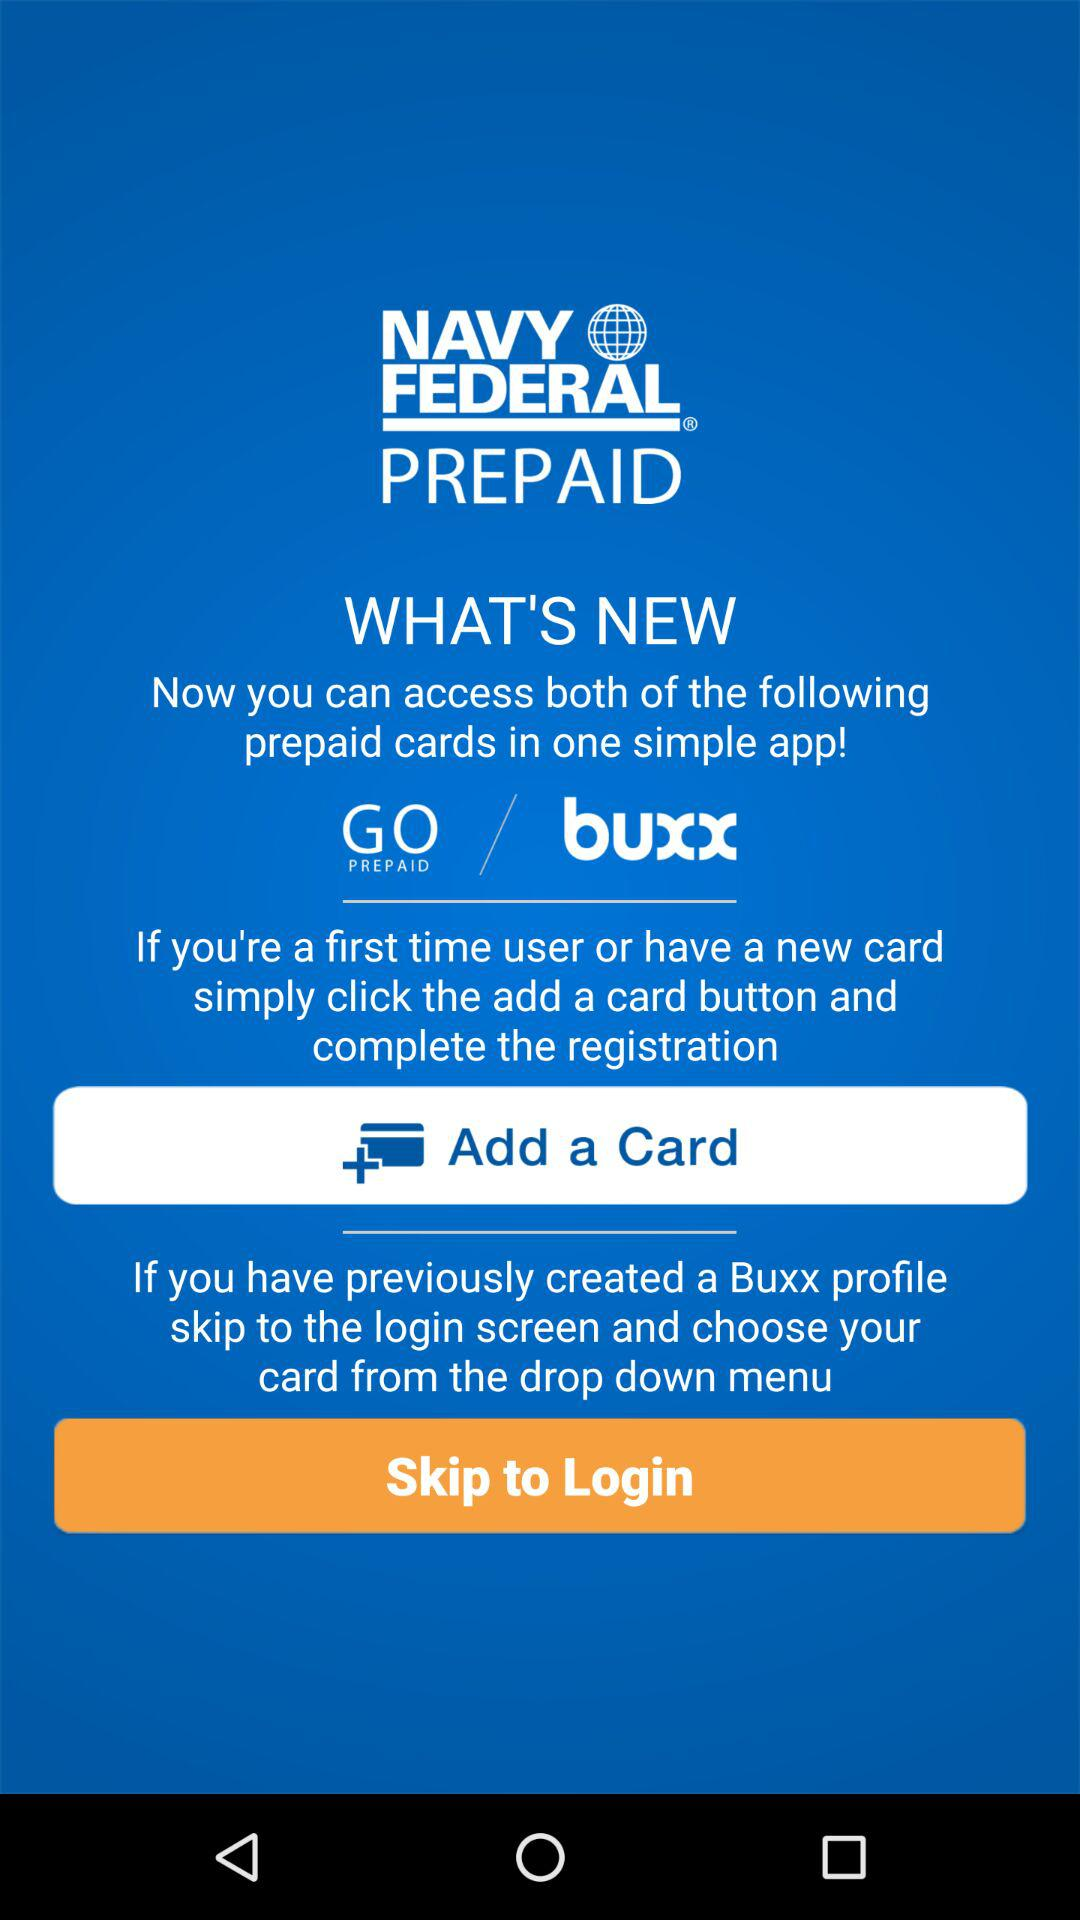What is the application name? The application name is "NAVY FEDERAL PREPAID". 